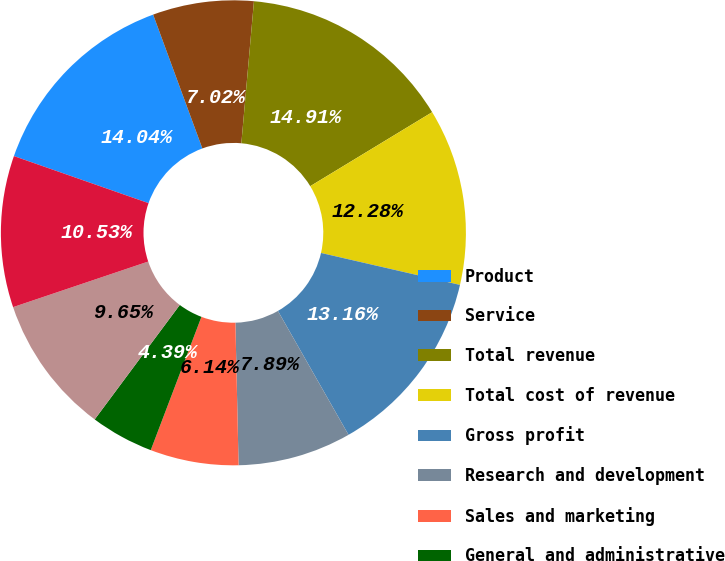<chart> <loc_0><loc_0><loc_500><loc_500><pie_chart><fcel>Product<fcel>Service<fcel>Total revenue<fcel>Total cost of revenue<fcel>Gross profit<fcel>Research and development<fcel>Sales and marketing<fcel>General and administrative<fcel>Total operating expenses<fcel>Income from operations<nl><fcel>14.04%<fcel>7.02%<fcel>14.91%<fcel>12.28%<fcel>13.16%<fcel>7.89%<fcel>6.14%<fcel>4.39%<fcel>9.65%<fcel>10.53%<nl></chart> 